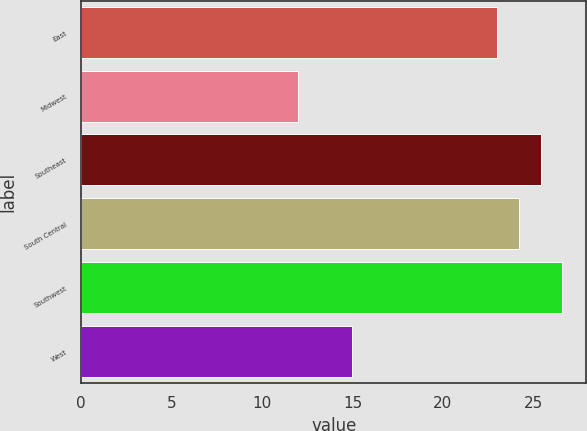Convert chart to OTSL. <chart><loc_0><loc_0><loc_500><loc_500><bar_chart><fcel>East<fcel>Midwest<fcel>Southeast<fcel>South Central<fcel>Southwest<fcel>West<nl><fcel>23<fcel>12<fcel>25.4<fcel>24.2<fcel>26.6<fcel>15<nl></chart> 